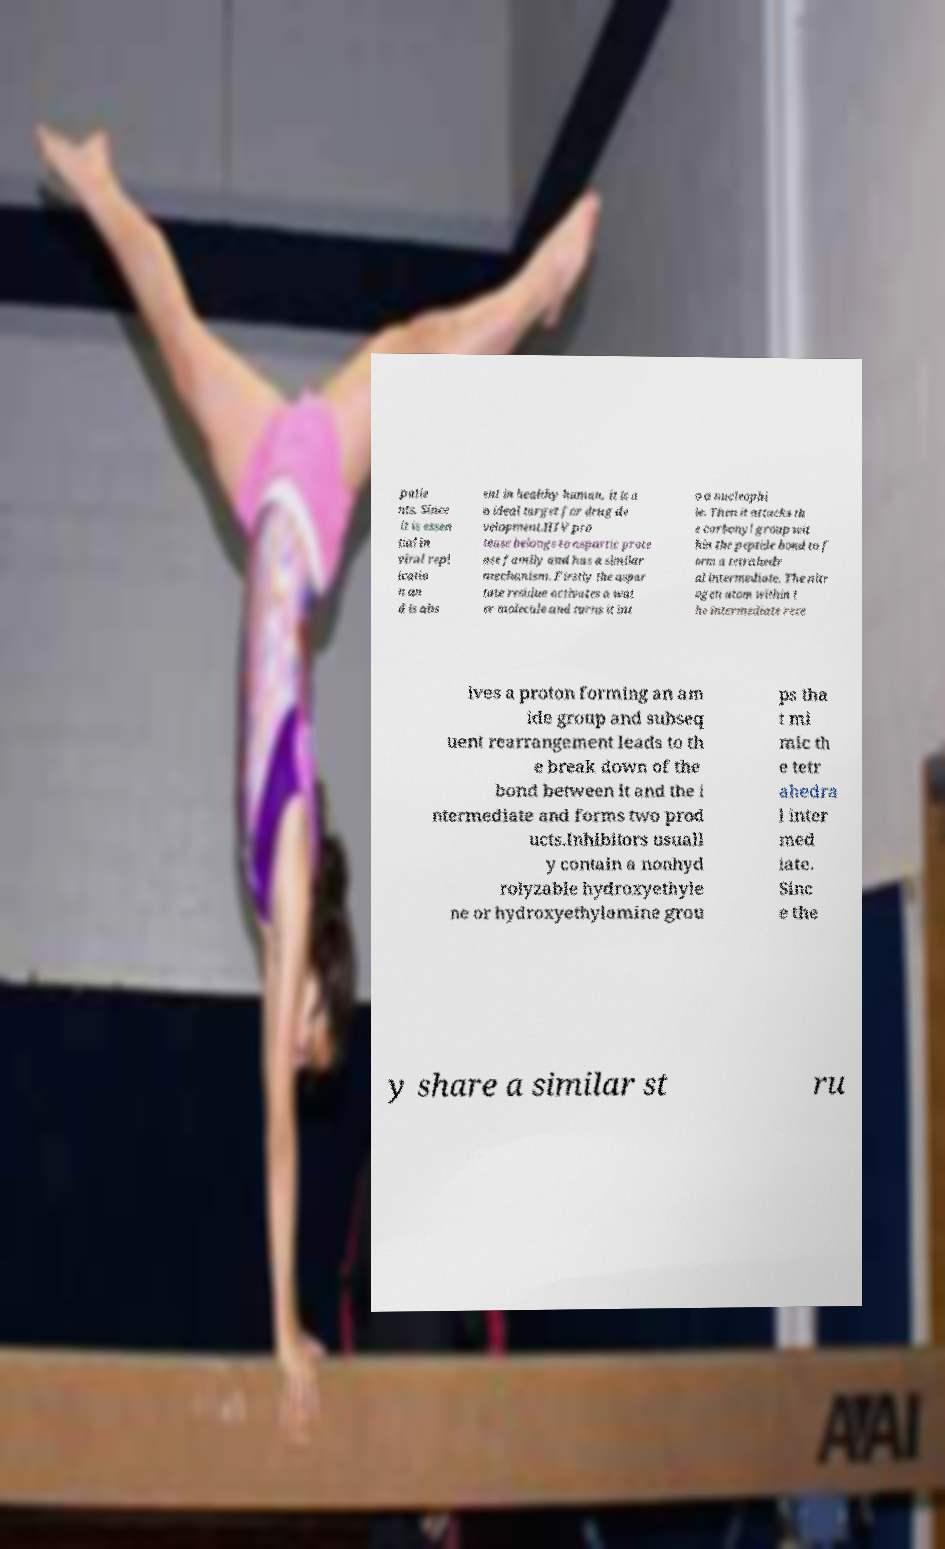Can you accurately transcribe the text from the provided image for me? patie nts. Since it is essen tial in viral repl icatio n an d is abs ent in healthy human, it is a n ideal target for drug de velopment.HIV pro tease belongs to aspartic prote ase family and has a similar mechanism. Firstly the aspar tate residue activates a wat er molecule and turns it int o a nucleophi le. Then it attacks th e carbonyl group wit hin the peptide bond to f orm a tetrahedr al intermediate. The nitr ogen atom within t he intermediate rece ives a proton forming an am ide group and subseq uent rearrangement leads to th e break down of the bond between it and the i ntermediate and forms two prod ucts.Inhibitors usuall y contain a nonhyd rolyzable hydroxyethyle ne or hydroxyethylamine grou ps tha t mi mic th e tetr ahedra l inter med iate. Sinc e the y share a similar st ru 